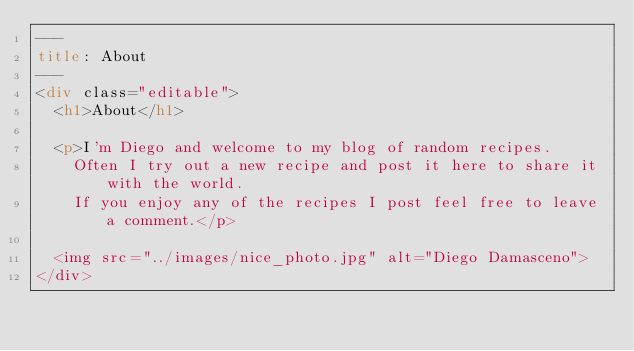<code> <loc_0><loc_0><loc_500><loc_500><_HTML_>---
title: About
---
<div class="editable">
	<h1>About</h1>

	<p>I'm Diego and welcome to my blog of random recipes.
		Often I try out a new recipe and post it here to share it with the world.
		If you enjoy any of the recipes I post feel free to leave a comment.</p>

	<img src="../images/nice_photo.jpg" alt="Diego Damasceno">
</div>
</code> 